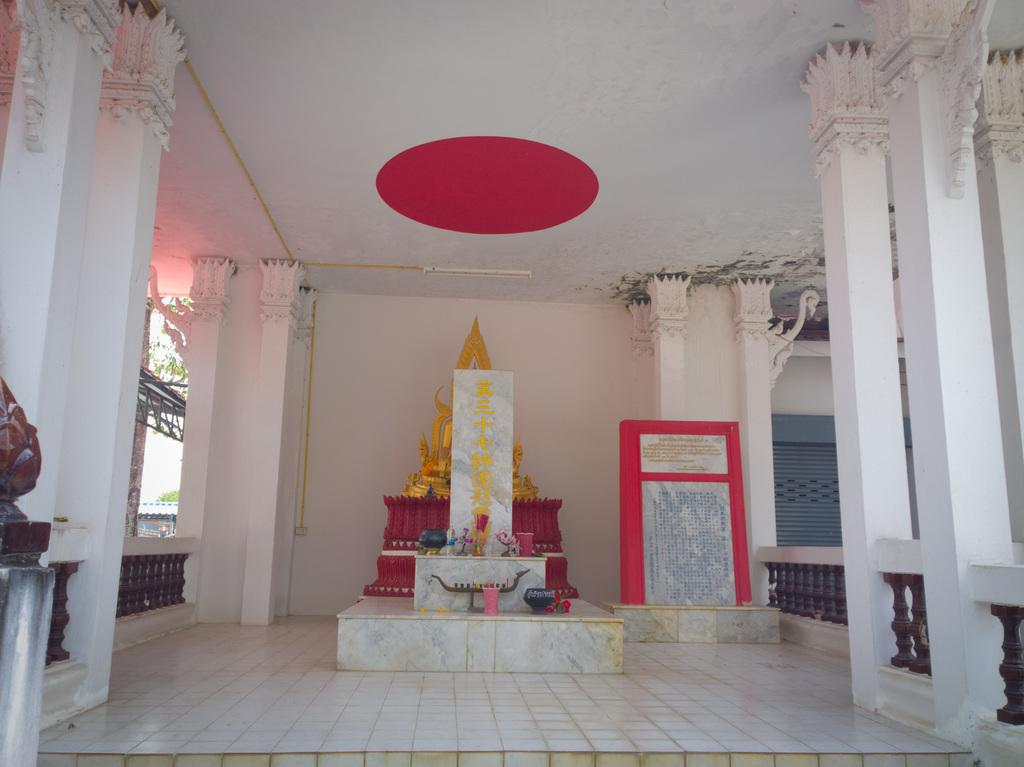What type of location is depicted in the image? The image is an inside view of a temple. What can be seen in the center of the image? There is a statue in the center of the image. What part of the temple is visible at the bottom of the image? The floor is visible at the bottom of the image. What type of advertisement can be seen on the statue in the image? There is no advertisement present on the statue in the image. What nerve is connected to the statue in the image? The image is a photograph and does not depict a living organism with nerves. 